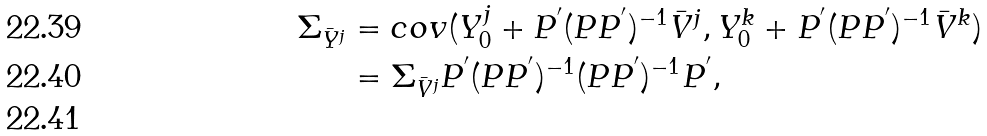Convert formula to latex. <formula><loc_0><loc_0><loc_500><loc_500>\Sigma _ { \bar { Y } ^ { j } } & = c o v ( Y _ { 0 } ^ { j } + P ^ { ^ { \prime } } ( P P ^ { ^ { \prime } } ) ^ { - 1 } \bar { V } ^ { j } , Y _ { 0 } ^ { k } + P ^ { ^ { \prime } } ( P P ^ { ^ { \prime } } ) ^ { - 1 } \bar { V } ^ { k } ) \\ & = \Sigma _ { \bar { V } ^ { j } } P ^ { ^ { \prime } } ( P P ^ { ^ { \prime } } ) ^ { - 1 } ( P P ^ { ^ { \prime } } ) ^ { - 1 } P ^ { ^ { \prime } } , \\</formula> 